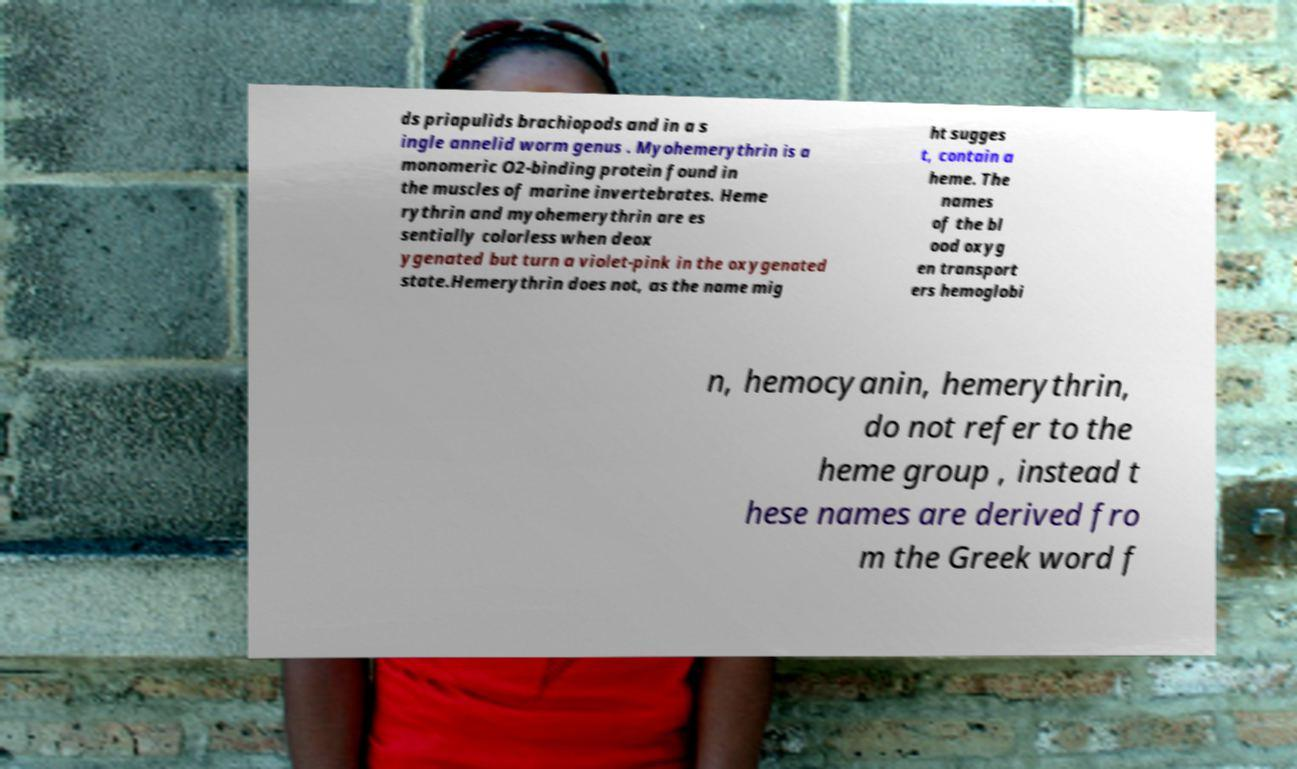For documentation purposes, I need the text within this image transcribed. Could you provide that? ds priapulids brachiopods and in a s ingle annelid worm genus . Myohemerythrin is a monomeric O2-binding protein found in the muscles of marine invertebrates. Heme rythrin and myohemerythrin are es sentially colorless when deox ygenated but turn a violet-pink in the oxygenated state.Hemerythrin does not, as the name mig ht sugges t, contain a heme. The names of the bl ood oxyg en transport ers hemoglobi n, hemocyanin, hemerythrin, do not refer to the heme group , instead t hese names are derived fro m the Greek word f 